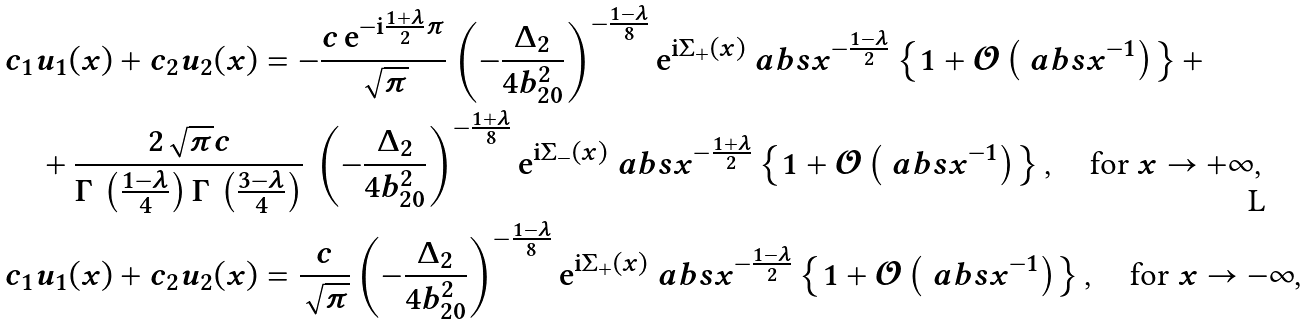<formula> <loc_0><loc_0><loc_500><loc_500>& c _ { 1 } u _ { 1 } ( x ) + c _ { 2 } u _ { 2 } ( x ) = - \frac { c \, \mathrm e ^ { - \mathrm i \frac { 1 + \lambda } { 2 } \pi } } { \sqrt { \pi } } \left ( - \frac { \Delta _ { 2 } } { 4 b _ { 2 0 } ^ { 2 } } \right ) ^ { - \frac { 1 - \lambda } 8 } \mathrm e ^ { \mathrm i \Sigma _ { + } ( x ) } \ a b s { x } ^ { - \frac { 1 - \lambda } 2 } \left \{ 1 + \mathcal { O } \left ( \ a b s { x } ^ { - 1 } \right ) \right \} + \\ & \quad + \frac { 2 \sqrt { \pi } c } { \Gamma \, \left ( \frac { 1 - \lambda } 4 \right ) \Gamma \, \left ( \frac { 3 - \lambda } 4 \right ) } \, \left ( - \frac { \Delta _ { 2 } } { 4 b _ { 2 0 } ^ { 2 } } \right ) ^ { - \frac { 1 + \lambda } 8 } \mathrm e ^ { \mathrm i \Sigma _ { - } ( x ) } \ a b s { x } ^ { - \frac { 1 + \lambda } 2 } \left \{ 1 + \mathcal { O } \left ( \ a b s { x } ^ { - 1 } \right ) \right \} , \quad \text {\upshape for $x\to+\infty$} , \\ & c _ { 1 } u _ { 1 } ( x ) + c _ { 2 } u _ { 2 } ( x ) = \frac { c } { \sqrt { \pi } } \left ( - \frac { \Delta _ { 2 } } { 4 b _ { 2 0 } ^ { 2 } } \right ) ^ { - \frac { 1 - \lambda } 8 } \mathrm e ^ { \mathrm i \Sigma _ { + } ( x ) } \ a b s { x } ^ { - \frac { 1 - \lambda } 2 } \left \{ 1 + \mathcal { O } \left ( \ a b s { x } ^ { - 1 } \right ) \right \} , \quad \text {\upshape for $x\to-\infty$} ,</formula> 